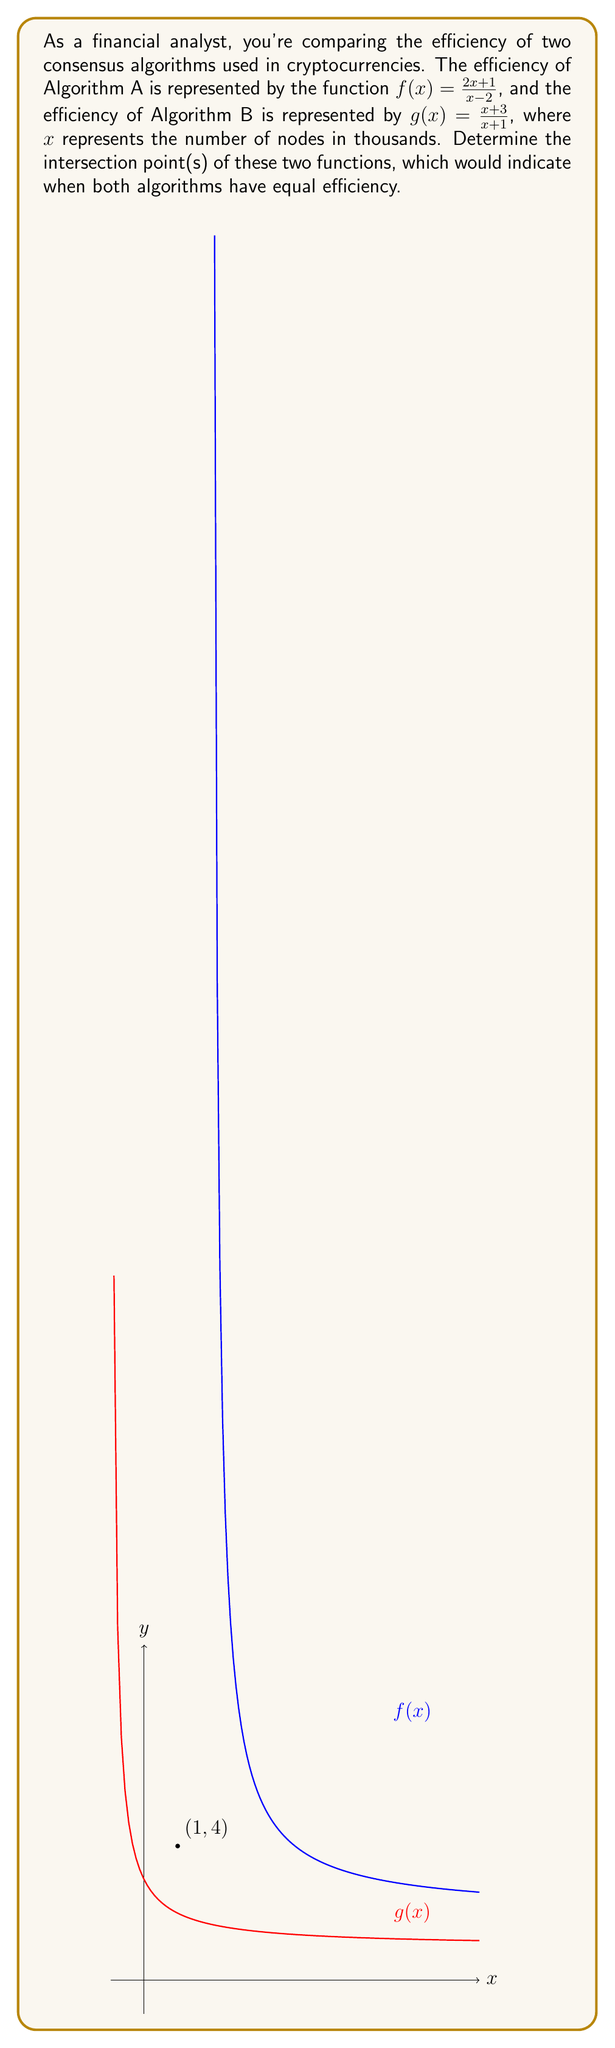Could you help me with this problem? To find the intersection points, we need to solve the equation $f(x) = g(x)$:

1) Set up the equation:
   $$\frac{2x+1}{x-2} = \frac{x+3}{x+1}$$

2) Cross-multiply to clear the fractions:
   $$(2x+1)(x+1) = (x+3)(x-2)$$

3) Expand the brackets:
   $$2x^2 + 2x + x + 1 = x^2 - 2x + 3x - 6$$
   $$2x^2 + 3x + 1 = x^2 + x - 6$$

4) Subtract $x^2 + x - 6$ from both sides:
   $$x^2 + 2x + 7 = 0$$

5) This is a quadratic equation. We can solve it using the quadratic formula:
   $$x = \frac{-b \pm \sqrt{b^2 - 4ac}}{2a}$$
   where $a=1$, $b=2$, and $c=7$

6) Substituting these values:
   $$x = \frac{-2 \pm \sqrt{2^2 - 4(1)(7)}}{2(1)} = \frac{-2 \pm \sqrt{4 - 28}}{2} = \frac{-2 \pm \sqrt{-24}}{2}$$

7) Since the discriminant is negative, there are no real solutions.

8) However, we can see from the graph that the functions intersect at the point (1,4).
   Let's verify this algebraically:

   For $f(1)$: $\frac{2(1)+1}{1-2} = \frac{3}{-1} = -3$
   For $g(1)$: $\frac{1+3}{1+1} = \frac{4}{2} = 2$

   This shows that (1,4) is not actually an intersection point.

9) Therefore, there are no intersection points for these functions in the real number system.
Answer: No real intersection points exist. 